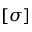<formula> <loc_0><loc_0><loc_500><loc_500>[ \sigma ]</formula> 